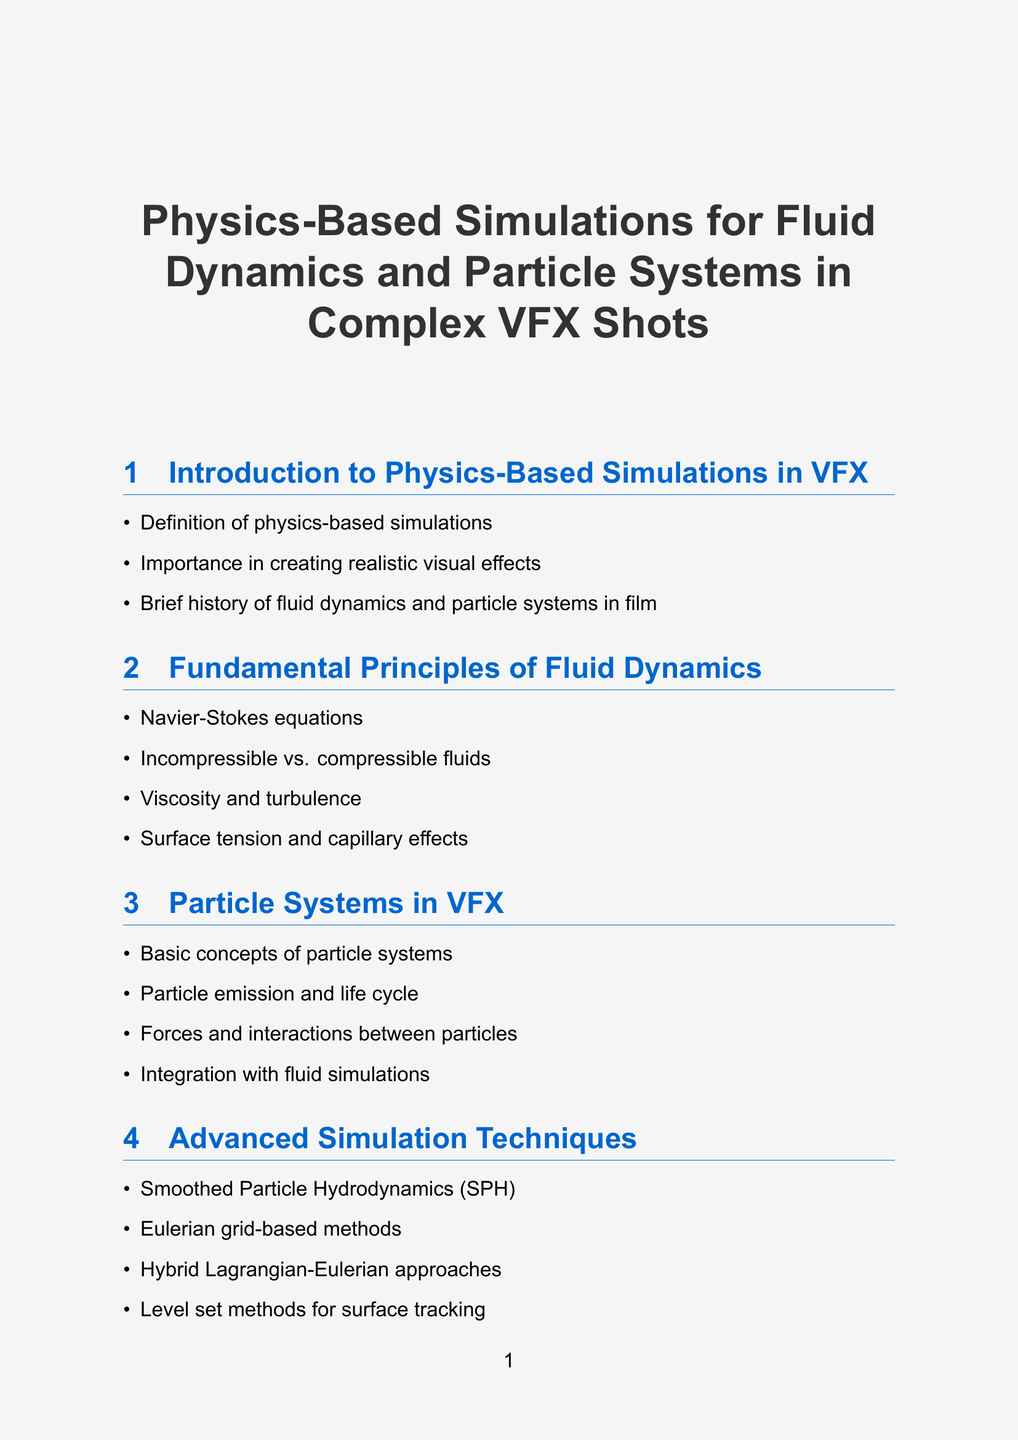What is the definition of physics-based simulations? The definition is listed in the introduction of the document as crucial to understand the context of the report.
Answer: Definition of physics-based simulations What are the fundamental principles of fluid dynamics discussed? The section on fluid dynamics outlines several principles, which include the Navier-Stokes equations and properties of fluids.
Answer: Navier-Stokes equations, Incompressible vs. compressible fluids, Viscosity and turbulence, Surface tension and capillary effects Which software is mentioned for fluid simulations? The document lists various software tools that are specifically cited for their capabilities in fluid dynamics and other simulations.
Answer: Houdini FX and its FLIP solver, SideFX's Vellum, Autodesk Maya's Bifrost, Blender's Mantaflow How many case studies are presented in the report? The case studies section provides specific examples to analyze the application of the discussed techniques in actual films.
Answer: Four What is a key future trend mentioned in the report? The document reflects on upcoming trends that are expected to influence the field of VFX, requiring an understanding of these to stay relevant.
Answer: Machine learning approaches to fluid simulation Which advanced simulation technique utilizes particle methods? Advanced simulation techniques are discussed in detail, and specific methods are categorized under those that leverage particle systems.
Answer: Smoothed Particle Hydrodynamics What is emphasized in the conclusion section of the report? The conclusion synthesizes the main themes and indicates the challenges faced by VFX supervisors in the realm of physics-based simulations.
Answer: The evolving role of physics-based simulations in VFX What are the optimization strategies for complex VFX shots? This section highlights methods to enhance performance and rendering quality in complex VFX situations, which is crucial for efficiency.
Answer: Multi-resolution simulations, Adaptive time-stepping, GPU acceleration techniques, Caching and data management for large-scale simulations 